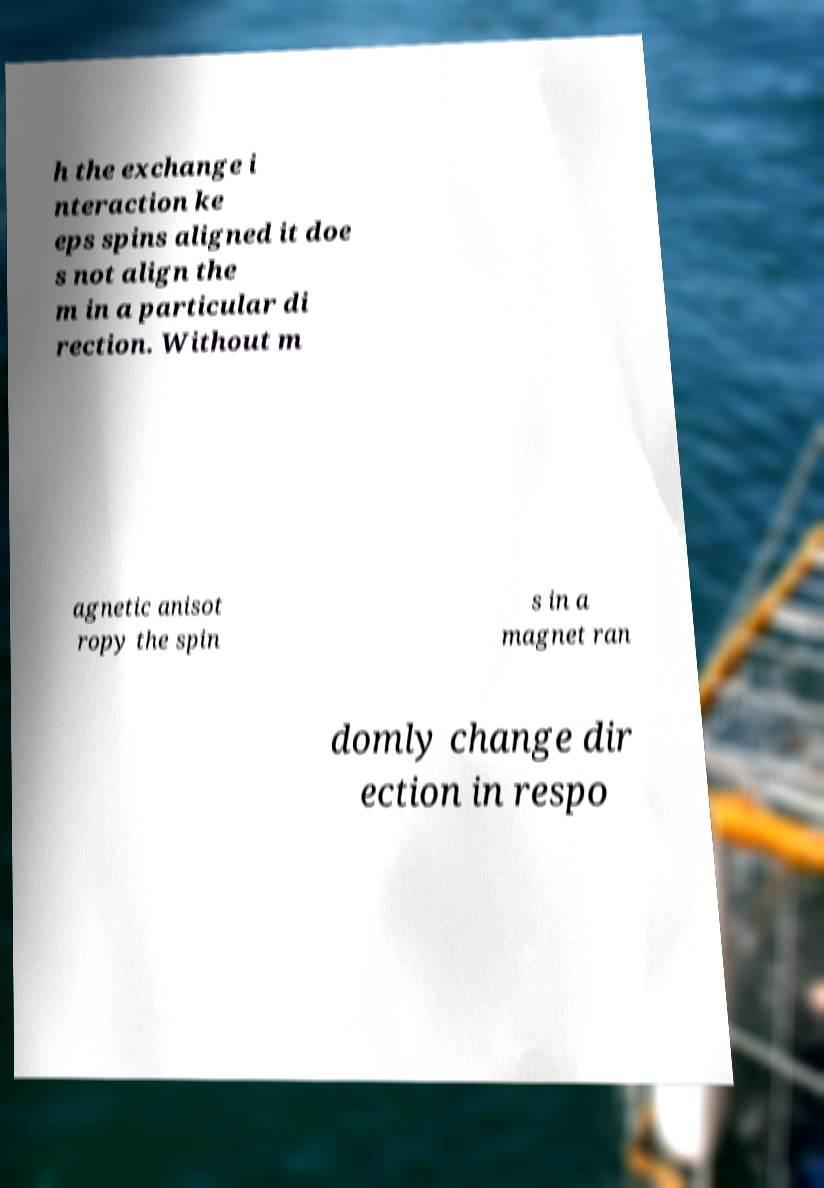There's text embedded in this image that I need extracted. Can you transcribe it verbatim? h the exchange i nteraction ke eps spins aligned it doe s not align the m in a particular di rection. Without m agnetic anisot ropy the spin s in a magnet ran domly change dir ection in respo 